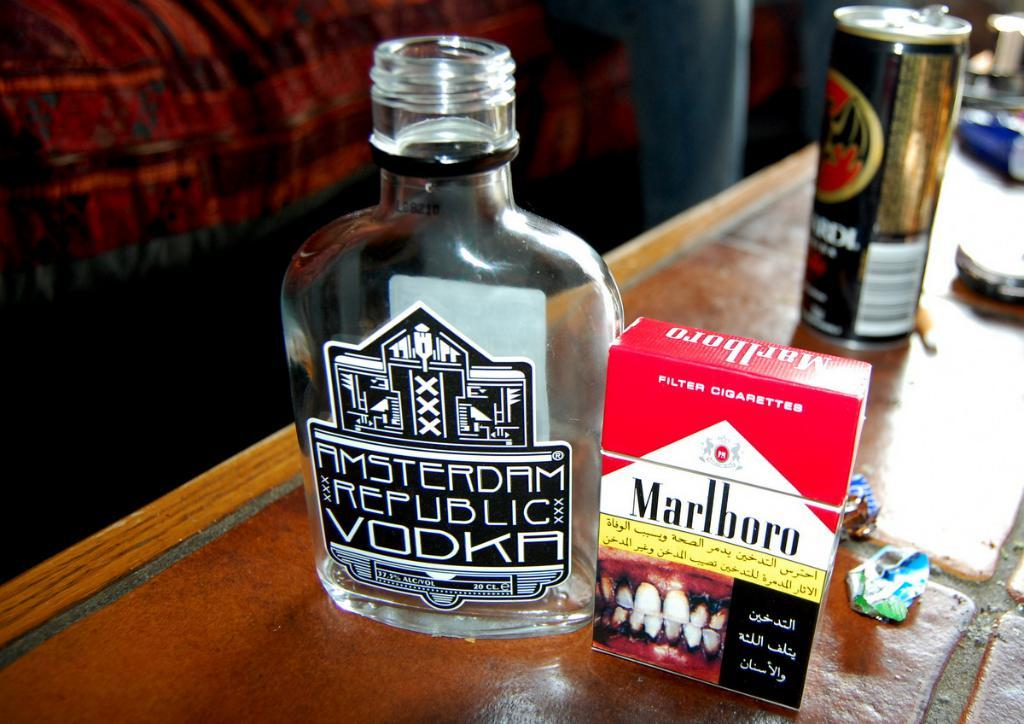What objects can be seen on the table in the image? There is a bottle, a box, and a tin on the table in the image. Are there any other items visible on the table? Yes, there are other items on the table. What can be seen in the background of the image? There is a red color cloth in the background. What type of van is parked next to the table in the image? There is no van present in the image; it only shows objects on a table and a red color cloth in the background. What note is written on the box in the image? There is no note written on the box in the image; it only shows a box, a bottle, and a tin on the table. 